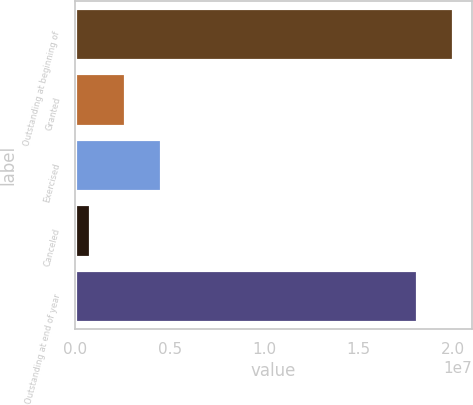<chart> <loc_0><loc_0><loc_500><loc_500><bar_chart><fcel>Outstanding at beginning of<fcel>Granted<fcel>Exercised<fcel>Canceled<fcel>Outstanding at end of year<nl><fcel>1.99821e+07<fcel>2.64204e+06<fcel>4.51925e+06<fcel>764825<fcel>1.81049e+07<nl></chart> 